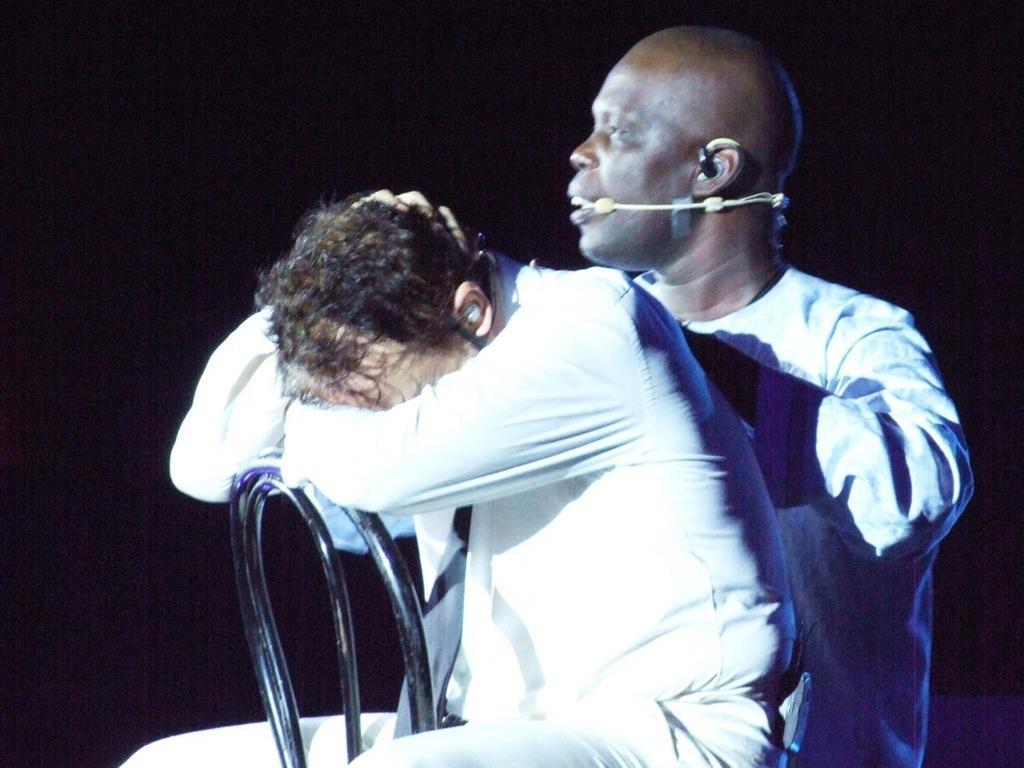Describe this image in one or two sentences. In this image we can see two persons are sitting on chairs, one of them is wearing a headset microphone, and the background is dark. 